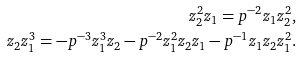<formula> <loc_0><loc_0><loc_500><loc_500>z _ { 2 } ^ { 2 } z _ { 1 } = p ^ { - 2 } z _ { 1 } z _ { 2 } ^ { 2 } , \\ z _ { 2 } z _ { 1 } ^ { 3 } = - p ^ { - 3 } z _ { 1 } ^ { 3 } z _ { 2 } - p ^ { - 2 } z _ { 1 } ^ { 2 } z _ { 2 } z _ { 1 } - p ^ { - 1 } z _ { 1 } z _ { 2 } z _ { 1 } ^ { 2 } .</formula> 